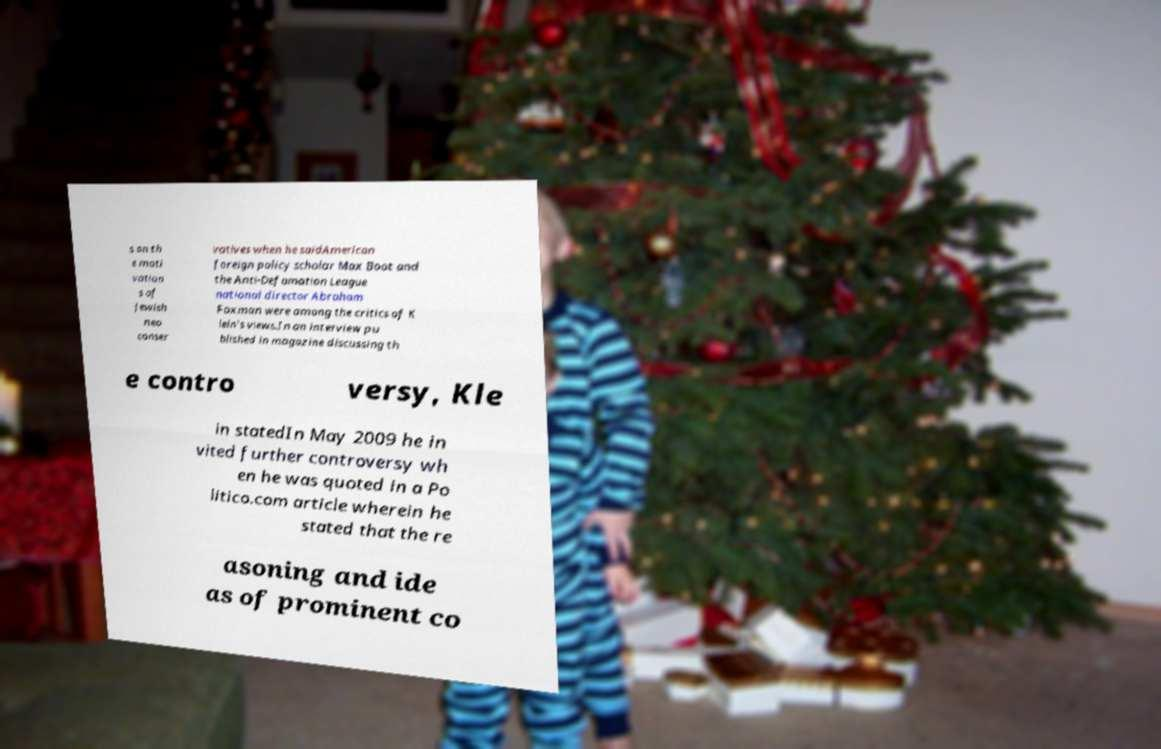What messages or text are displayed in this image? I need them in a readable, typed format. s on th e moti vation s of Jewish neo conser vatives when he saidAmerican foreign policy scholar Max Boot and the Anti-Defamation League national director Abraham Foxman were among the critics of K lein's views.In an interview pu blished in magazine discussing th e contro versy, Kle in statedIn May 2009 he in vited further controversy wh en he was quoted in a Po litico.com article wherein he stated that the re asoning and ide as of prominent co 